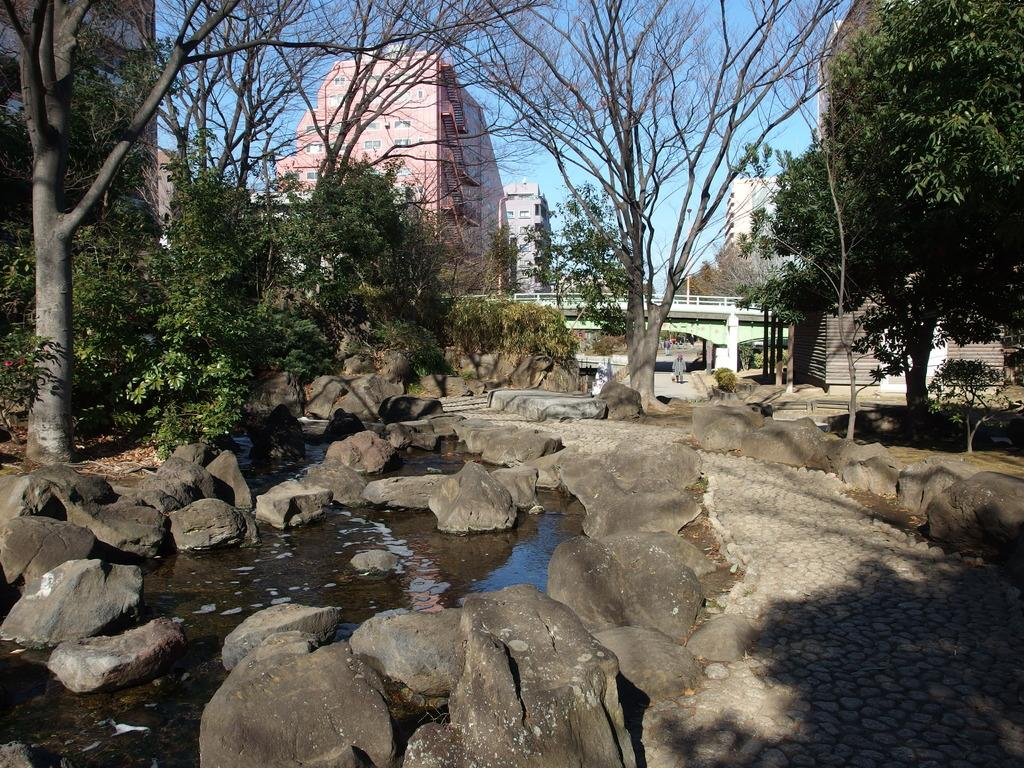What is the primary element in the image? There is water in the image. What other natural elements can be seen in the image? There are rocks and trees in the image. What man-made structures are visible in the background of the image? There is a bridge and buildings in the background of the image. What is the color of the sky in the image? The sky is blue in the image. Where is the playground apparatus located in the image? There is no playground apparatus present in the image. How many boys can be seen playing on the apparatus in the image? There are no boys or playground apparatus present in the image. 